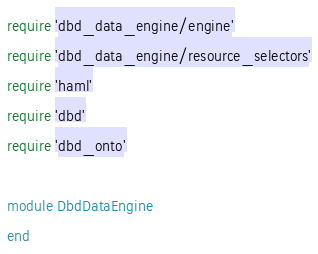<code> <loc_0><loc_0><loc_500><loc_500><_Ruby_>require 'dbd_data_engine/engine'
require 'dbd_data_engine/resource_selectors'
require 'haml'
require 'dbd'
require 'dbd_onto'

module DbdDataEngine
end
</code> 